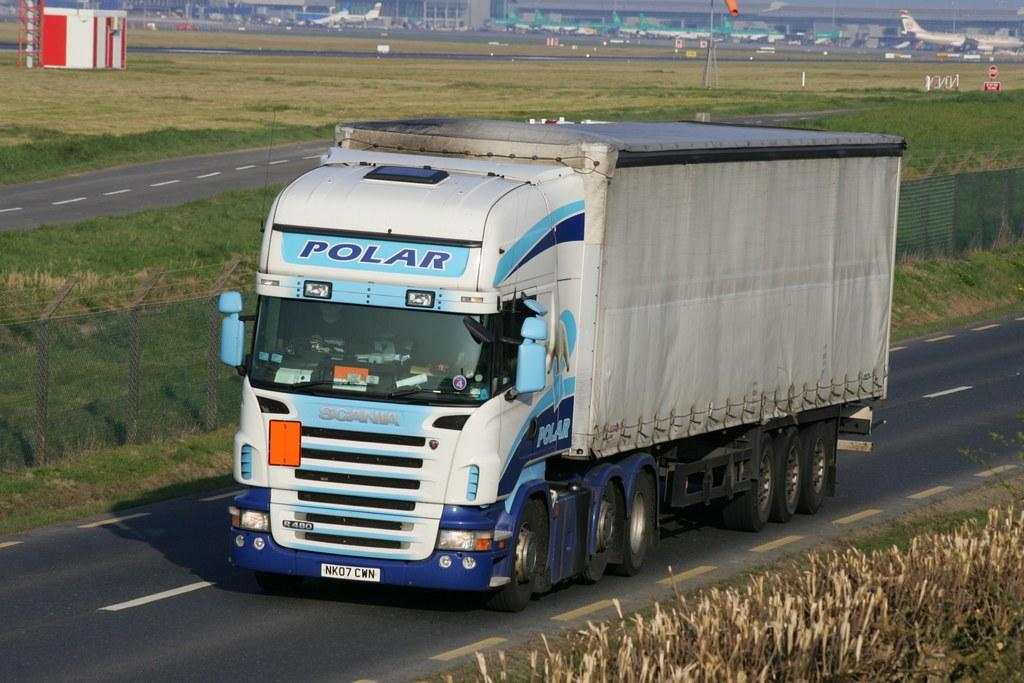What type of vehicle can be seen on the road in the image? There is a motor vehicle on the road in the image. What type of natural environment is visible in the image? There is grass visible in the image. What type of transportation is depicted in the sky in the image? There are aeroplanes in the image. What type of structures can be seen in the image? There are buildings in the image. What type of signage is present in the image? There are information boards in the image. How many children are playing in the grass in the image? There are no children present in the image; it features a motor vehicle, grass, aeroplanes, buildings, and information boards. What type of battle is taking place in the image? There is no battle present in the image; it features a motor vehicle, grass, aeroplanes, buildings, and information boards. 